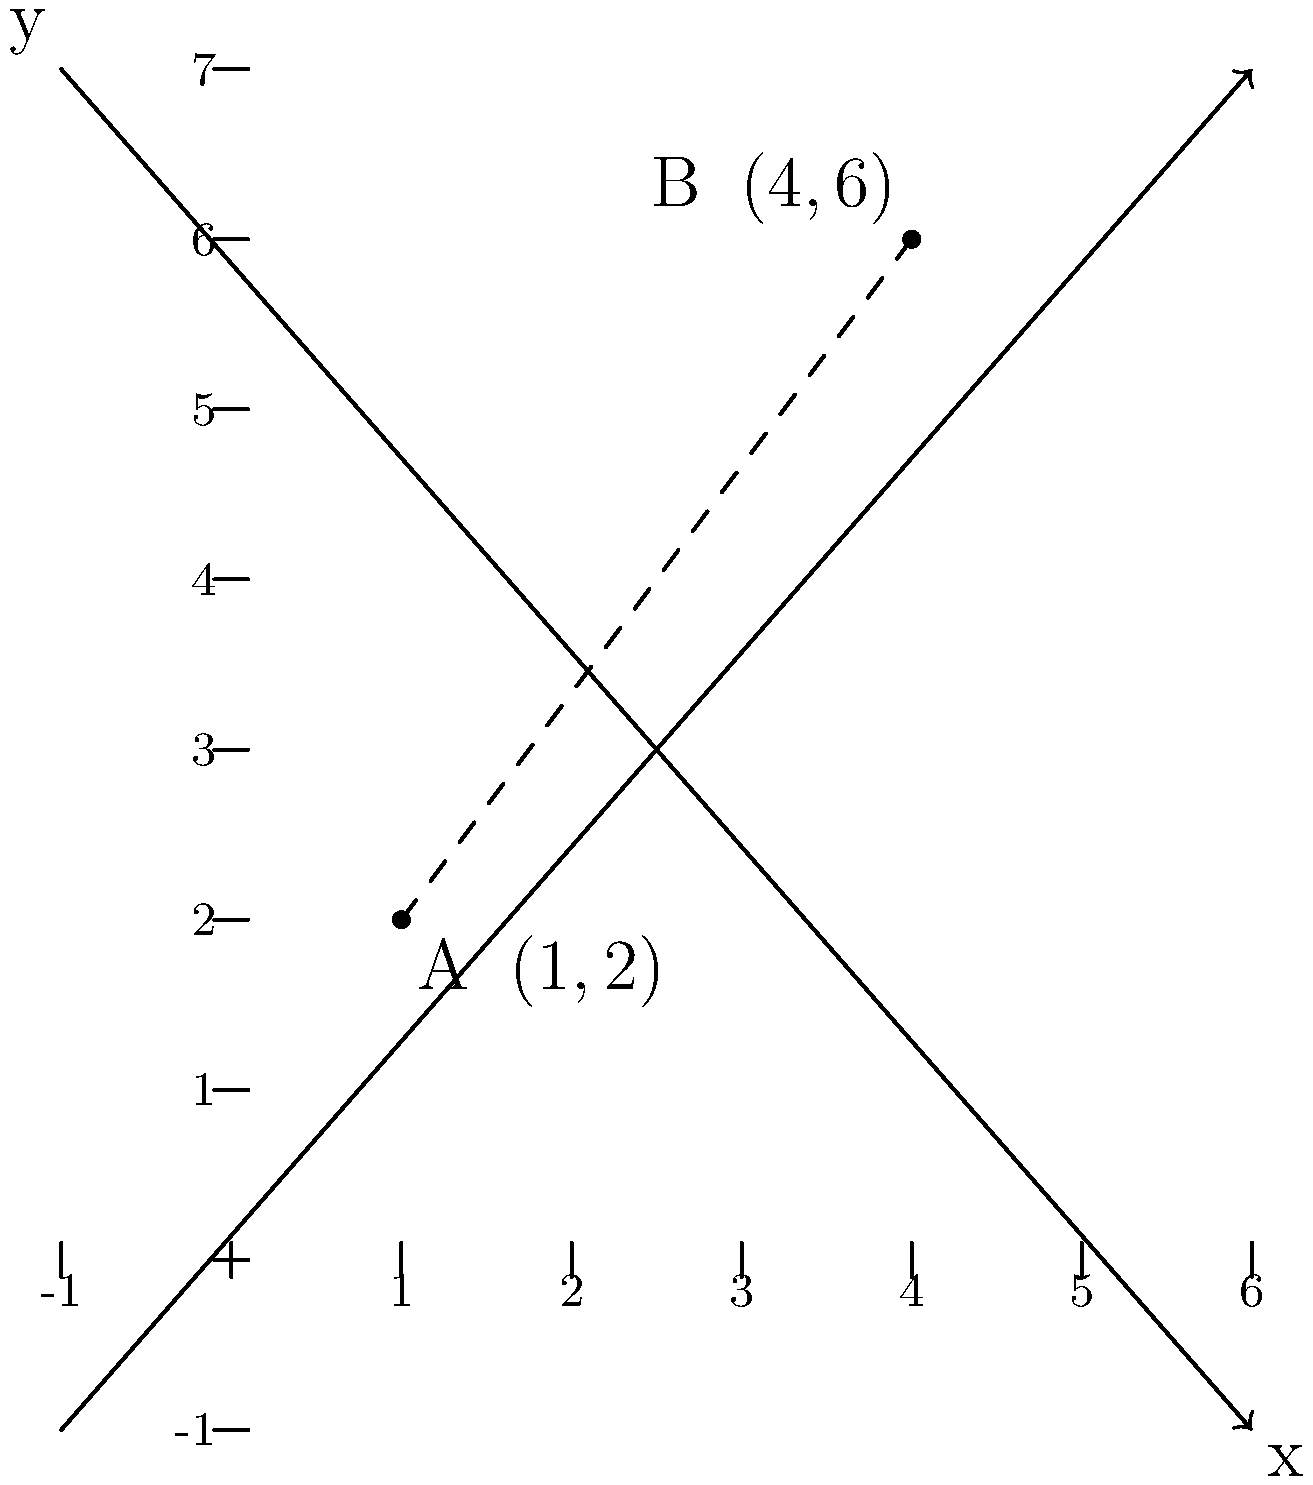In the battle for digital freedom, two social media influencers, A and B, are positioned on a coordinate plane representing their stance on various issues. Influencer A is at point (1,2), while Influencer B is at (4,6). To understand the ideological gap between them, calculate the distance between these two points using the distance formula. Round your answer to two decimal places. To find the distance between two points on a coordinate plane, we use the distance formula:

$$d = \sqrt{(x_2 - x_1)^2 + (y_2 - y_1)^2}$$

Where $(x_1, y_1)$ are the coordinates of the first point and $(x_2, y_2)$ are the coordinates of the second point.

Let's plug in our values:
- Point A: $(x_1, y_1) = (1, 2)$
- Point B: $(x_2, y_2) = (4, 6)$

Now, let's calculate step by step:

1) $d = \sqrt{(4 - 1)^2 + (6 - 2)^2}$

2) $d = \sqrt{3^2 + 4^2}$

3) $d = \sqrt{9 + 16}$

4) $d = \sqrt{25}$

5) $d = 5$

The exact distance is 5 units. Since the question asks for the answer rounded to two decimal places, our final answer is 5.00.

This distance represents the ideological gap between the two influencers in the digital freedom space.
Answer: 5.00 